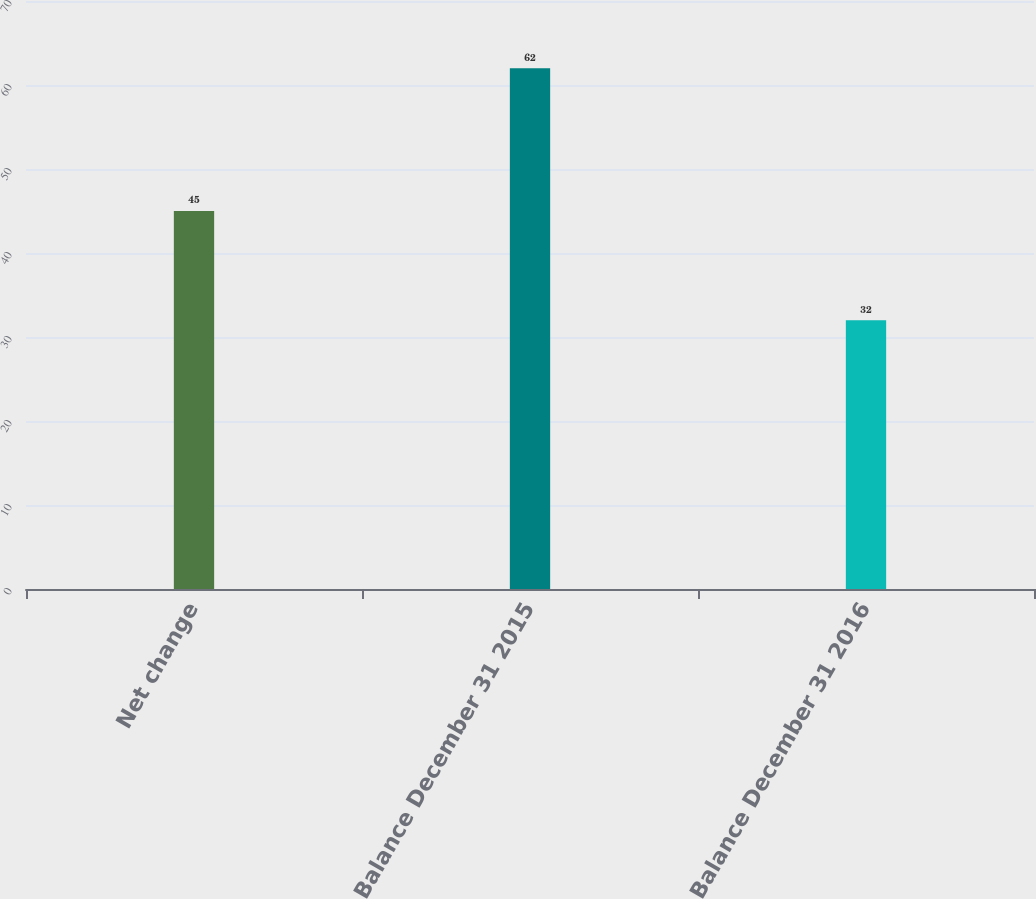<chart> <loc_0><loc_0><loc_500><loc_500><bar_chart><fcel>Net change<fcel>Balance December 31 2015<fcel>Balance December 31 2016<nl><fcel>45<fcel>62<fcel>32<nl></chart> 